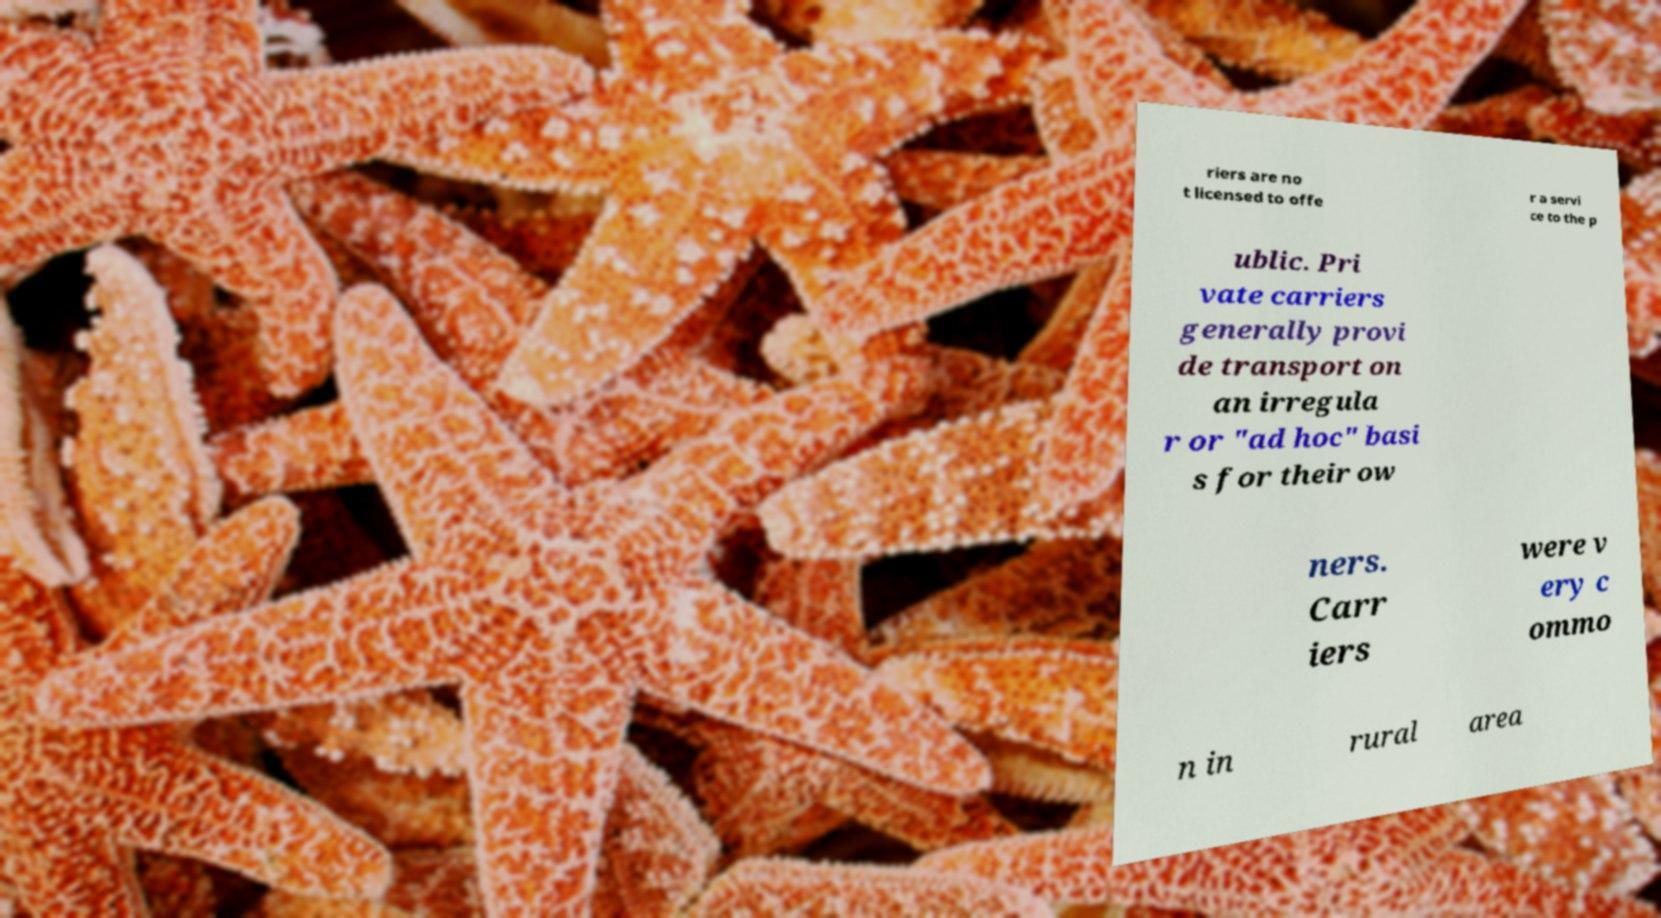What messages or text are displayed in this image? I need them in a readable, typed format. riers are no t licensed to offe r a servi ce to the p ublic. Pri vate carriers generally provi de transport on an irregula r or "ad hoc" basi s for their ow ners. Carr iers were v ery c ommo n in rural area 